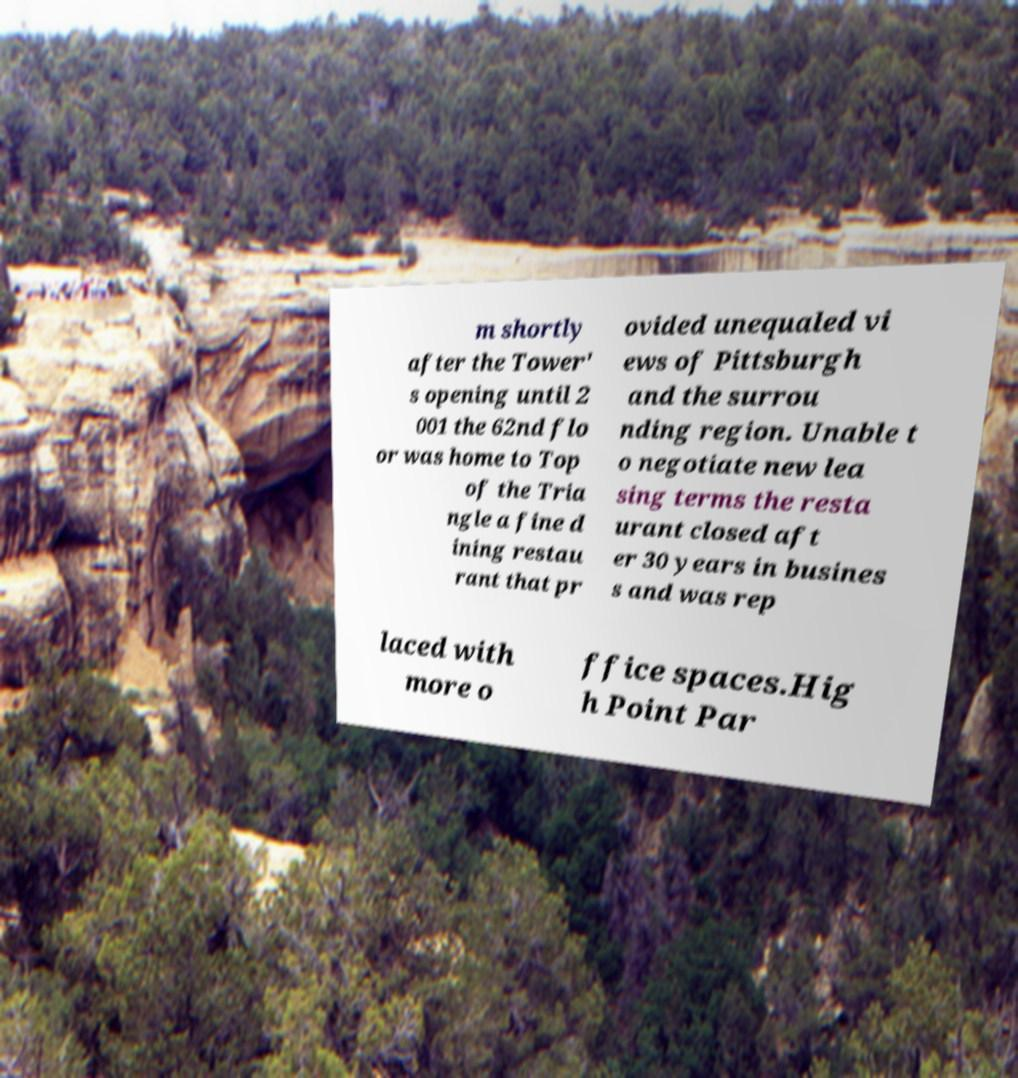For documentation purposes, I need the text within this image transcribed. Could you provide that? m shortly after the Tower' s opening until 2 001 the 62nd flo or was home to Top of the Tria ngle a fine d ining restau rant that pr ovided unequaled vi ews of Pittsburgh and the surrou nding region. Unable t o negotiate new lea sing terms the resta urant closed aft er 30 years in busines s and was rep laced with more o ffice spaces.Hig h Point Par 